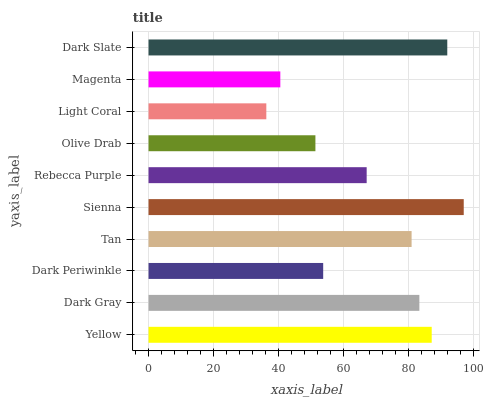Is Light Coral the minimum?
Answer yes or no. Yes. Is Sienna the maximum?
Answer yes or no. Yes. Is Dark Gray the minimum?
Answer yes or no. No. Is Dark Gray the maximum?
Answer yes or no. No. Is Yellow greater than Dark Gray?
Answer yes or no. Yes. Is Dark Gray less than Yellow?
Answer yes or no. Yes. Is Dark Gray greater than Yellow?
Answer yes or no. No. Is Yellow less than Dark Gray?
Answer yes or no. No. Is Tan the high median?
Answer yes or no. Yes. Is Rebecca Purple the low median?
Answer yes or no. Yes. Is Yellow the high median?
Answer yes or no. No. Is Dark Periwinkle the low median?
Answer yes or no. No. 